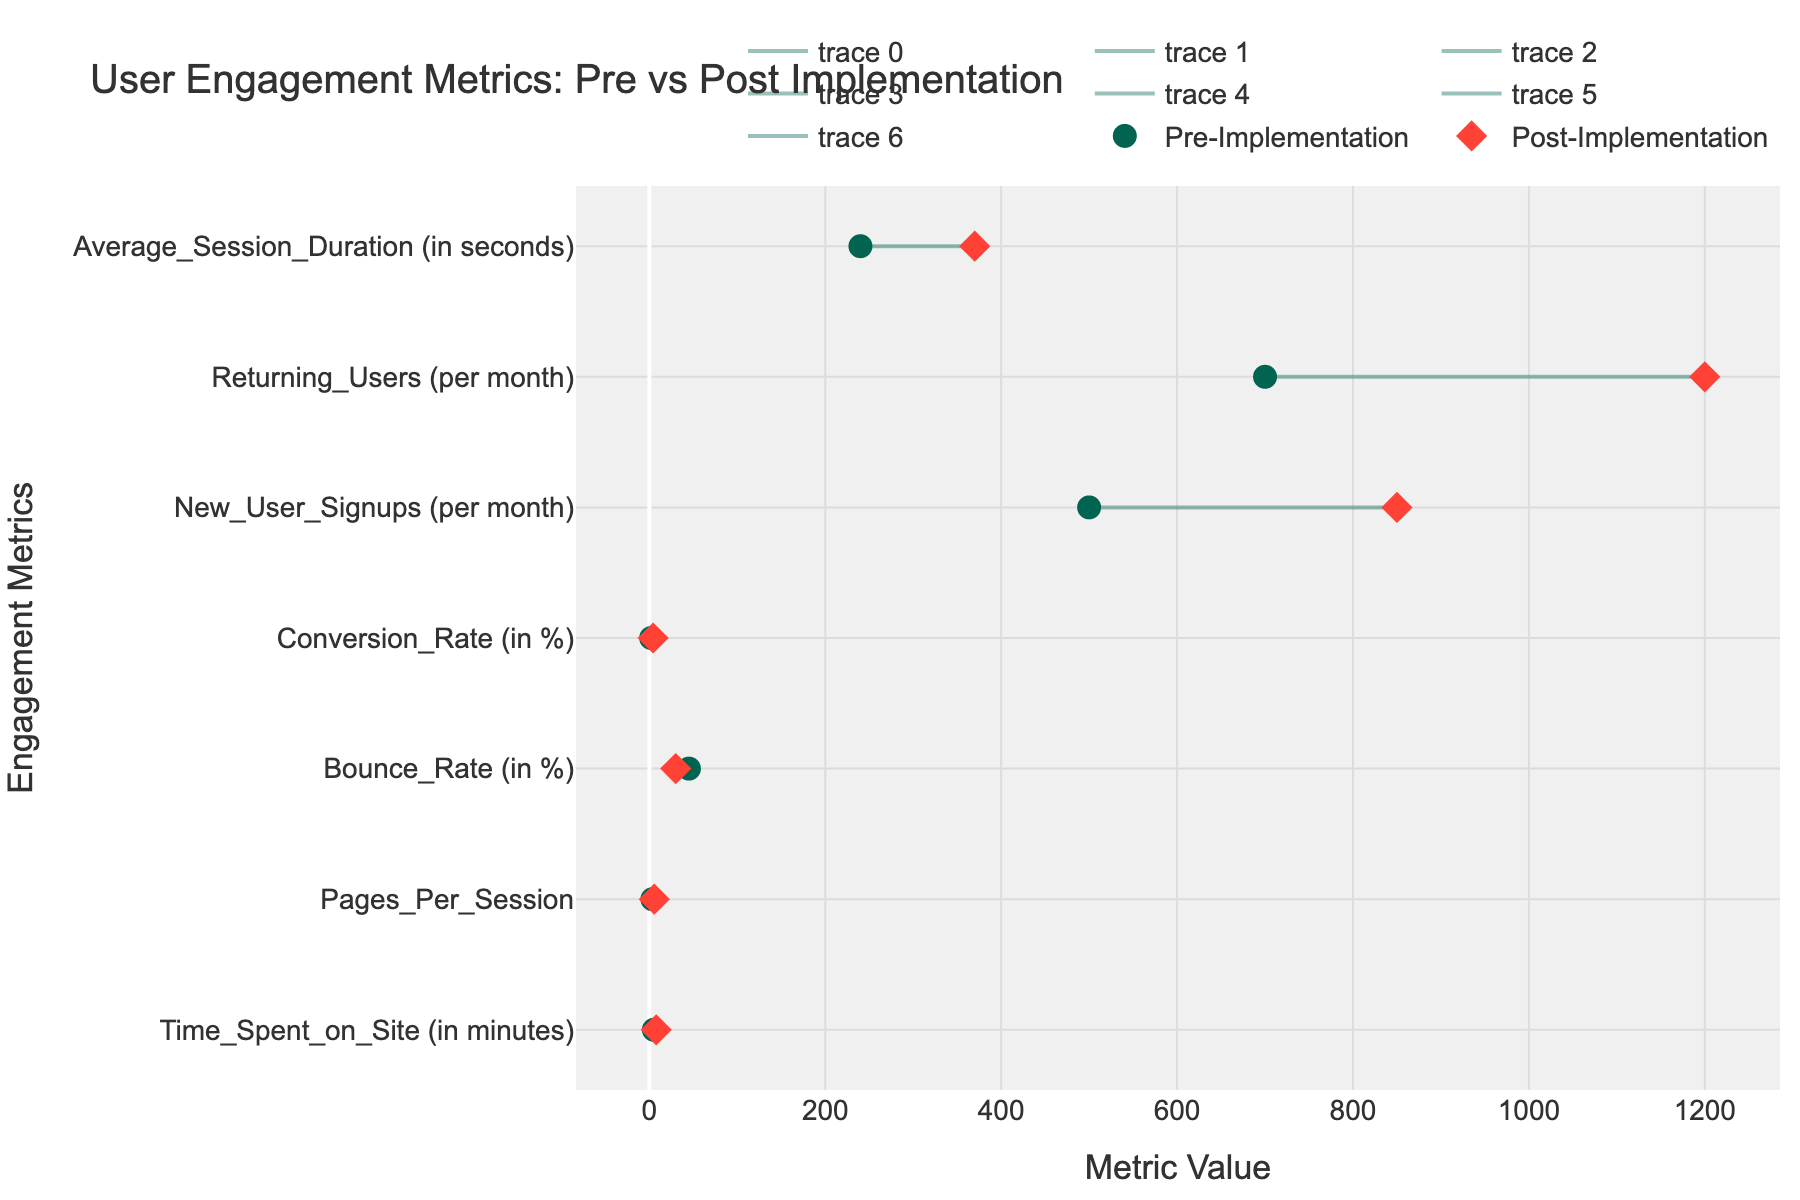what is the title of the figure? To find the title of the figure, look at the text displayed at the top of the graph.
Answer: User Engagement Metrics: Pre vs Post Implementation What are the two colors used for the pre- and post-implementation markers? The colors of the markers can be identified by looking at the legend in the figure; the markers for pre-implementation are in one color and post-implementation in another.
Answer: Green and Red What's the difference in Conversion Rate between pre- and post-implementation? First, locate the Conversion Rate on the y-axis, then find the values for pre-implementation and post-implementation on the x-axis. Subtract the pre-implementation value from the post-implementation value: 4.3 - 2.1.
Answer: 2.2% Which metric shows the largest improvement post-implementation compared to pre-implementation? To determine the largest improvement, find the differences between post- and pre-implementation values for all metrics, then identify the metric with the highest difference. The differences are: Time Spent (2.6), Pages Per Session (2.1), Bounce Rate (-15), Conversion Rate (2.2), New User Signups (350), Returning Users (500), Average Session Duration (130).
Answer: Returning Users What's the average of the post-implementation values for New User Signups and Returning Users? Locate the New User Signups and Returning Users on the y-axis. Note their post-implementation values: 850 and 1200. Add them together and divide by 2: (850 + 1200) / 2.
Answer: 1025 Which metric has decreased after the implementation? Check for the metrics whose post-implementation value is less than the pre-implementation value. This can be observed by noting which line extends to the left from pre- to post-implementation.
Answer: Bounce Rate What's the overall trend observed in user engagement metrics after the implementation of Sales Insight? Evaluate if the metrics generally increased or decreased by comparing the pre- and post-implementation markers.
Answer: Improvement What is the second-largest increase in user engagement metrics post-implementation? Calculate the increases for each metric and then sort them to find the second largest increase: Time Spent (2.6), Pages Per Session (2.1), Bounce Rate (-15), Conversion Rate (2.2), New User Signups (350), Returning Users (500), Average Session Duration (130). The second largest is 350 (New User Signups).
Answer: New User Signups How many metrics fall below 50 units in pre-implementation values? Examine the x-axis values of pre-implementation markers and count how many metrics have values below 50: the metrics are Time Spent (5.2), Pages Per Session (3.5), Bounce Rate (45), Conversion Rate (2.1).
Answer: 4 metrics How many total engagement metrics are being tracked in the figure? Count the number of distinct metrics listed on the y-axis in the figure.
Answer: 7 metrics 